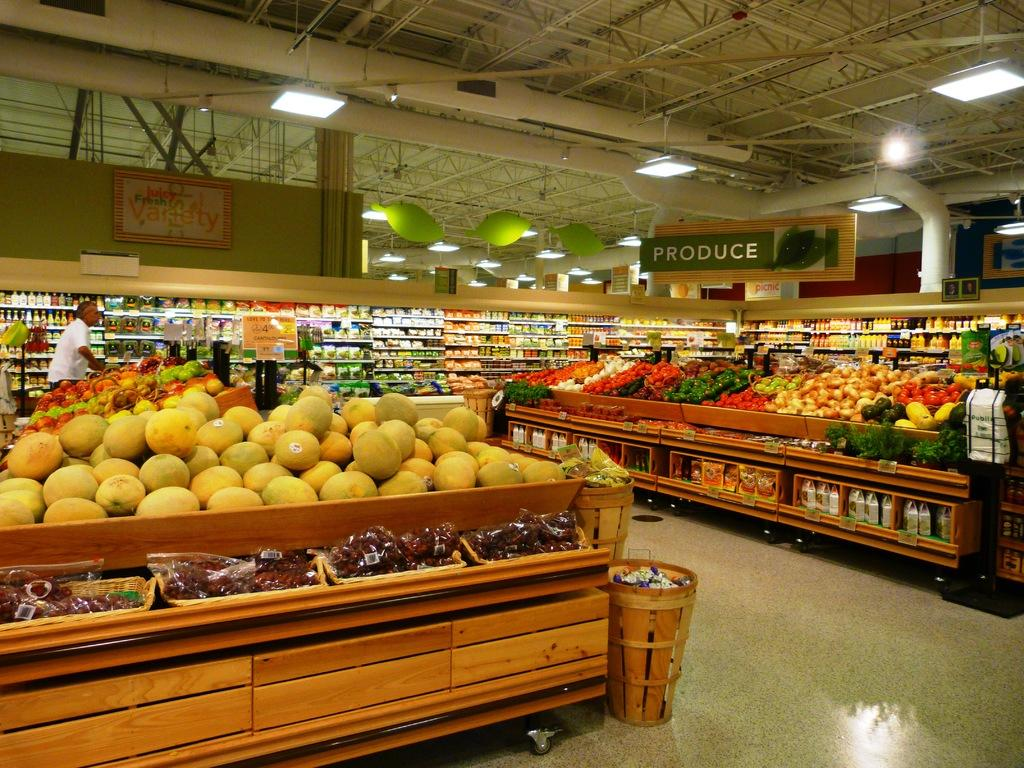<image>
Relay a brief, clear account of the picture shown. A green sign labels the Produce section of a supermarket. 